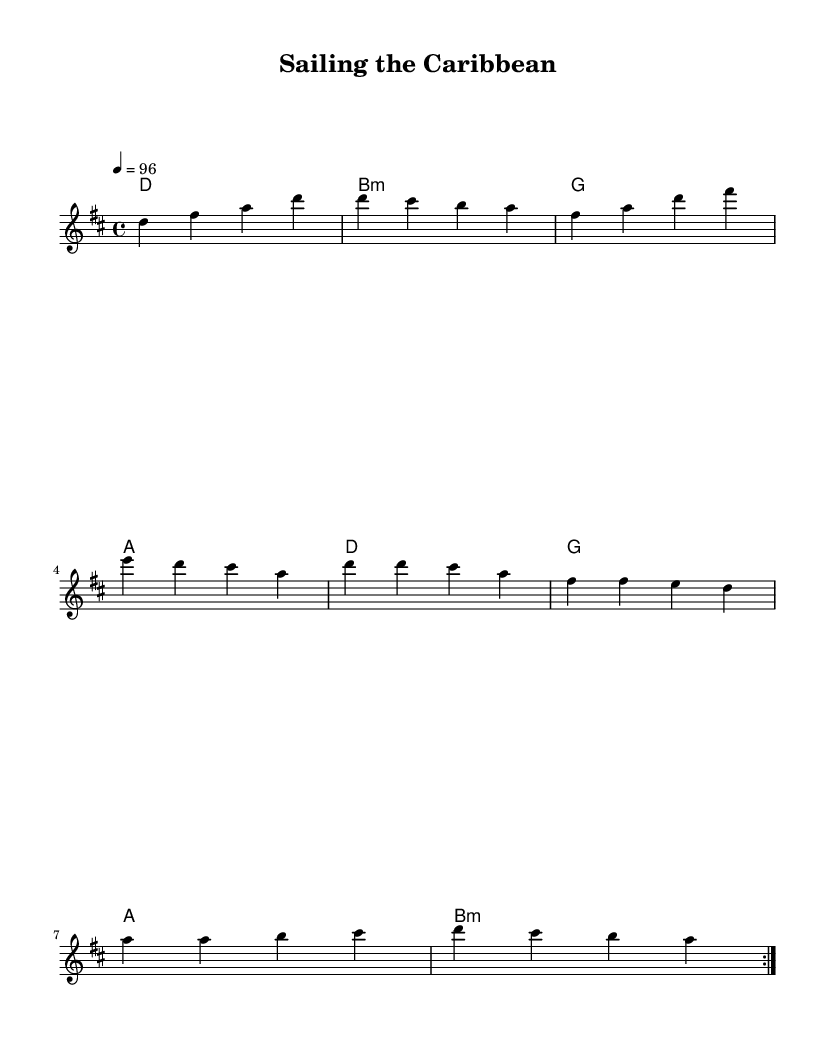What is the key signature of this music? The key signature is D major, indicated by two sharps (F# and C#) on the staff.
Answer: D major What is the time signature of the music? The time signature is 4/4, which means there are four beats in a measure and a quarter note gets one beat.
Answer: 4/4 What is the tempo marking for the piece? The tempo marking is 96 beats per minute, indicated by the tempo instruction at the beginning of the score.
Answer: 96 How many measures are repeated in the melody section? The melody section has a repeated section marked by "volta," which indicates that it should be played twice. Counting the measures included in the repeated section shows that it repeats four measures.
Answer: 2 What is the last chord of the piece? The last chord in the harmonies section is B minor, shown in the chord sequence at the end of the score.
Answer: B minor How many different chords are used in the harmonies section? The chord sequence includes four different chords: D major, B minor, G major, and A major. Counting these reveals there are four distinct chords used throughout.
Answer: 4 What mood or theme does the music evoke based on its title and rhythmic style? The title "Sailing the Caribbean" suggests a relaxed and adventurous feeling, typical of tropical reggaeton, which emphasizes dance and coastal life, as indicated by the melody and rhythm.
Answer: Adventurous 